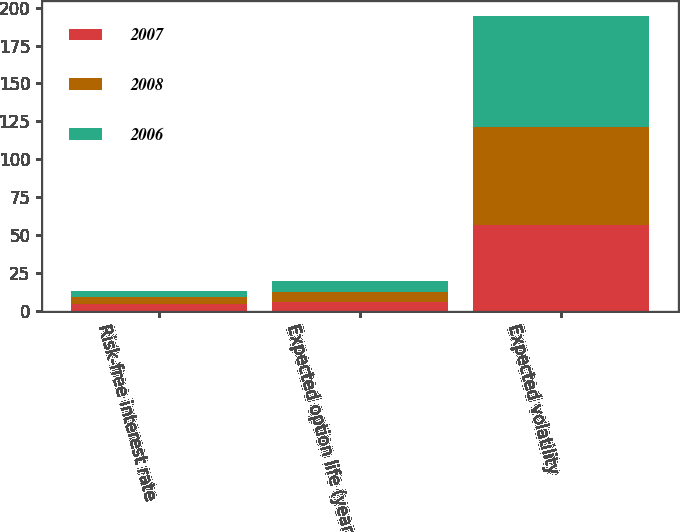<chart> <loc_0><loc_0><loc_500><loc_500><stacked_bar_chart><ecel><fcel>Risk-free interest rate<fcel>Expected option life (years)<fcel>Expected volatility<nl><fcel>2007<fcel>4.38<fcel>5.93<fcel>56.6<nl><fcel>2008<fcel>4.97<fcel>6.25<fcel>65<nl><fcel>2006<fcel>4.14<fcel>7.3<fcel>73<nl></chart> 